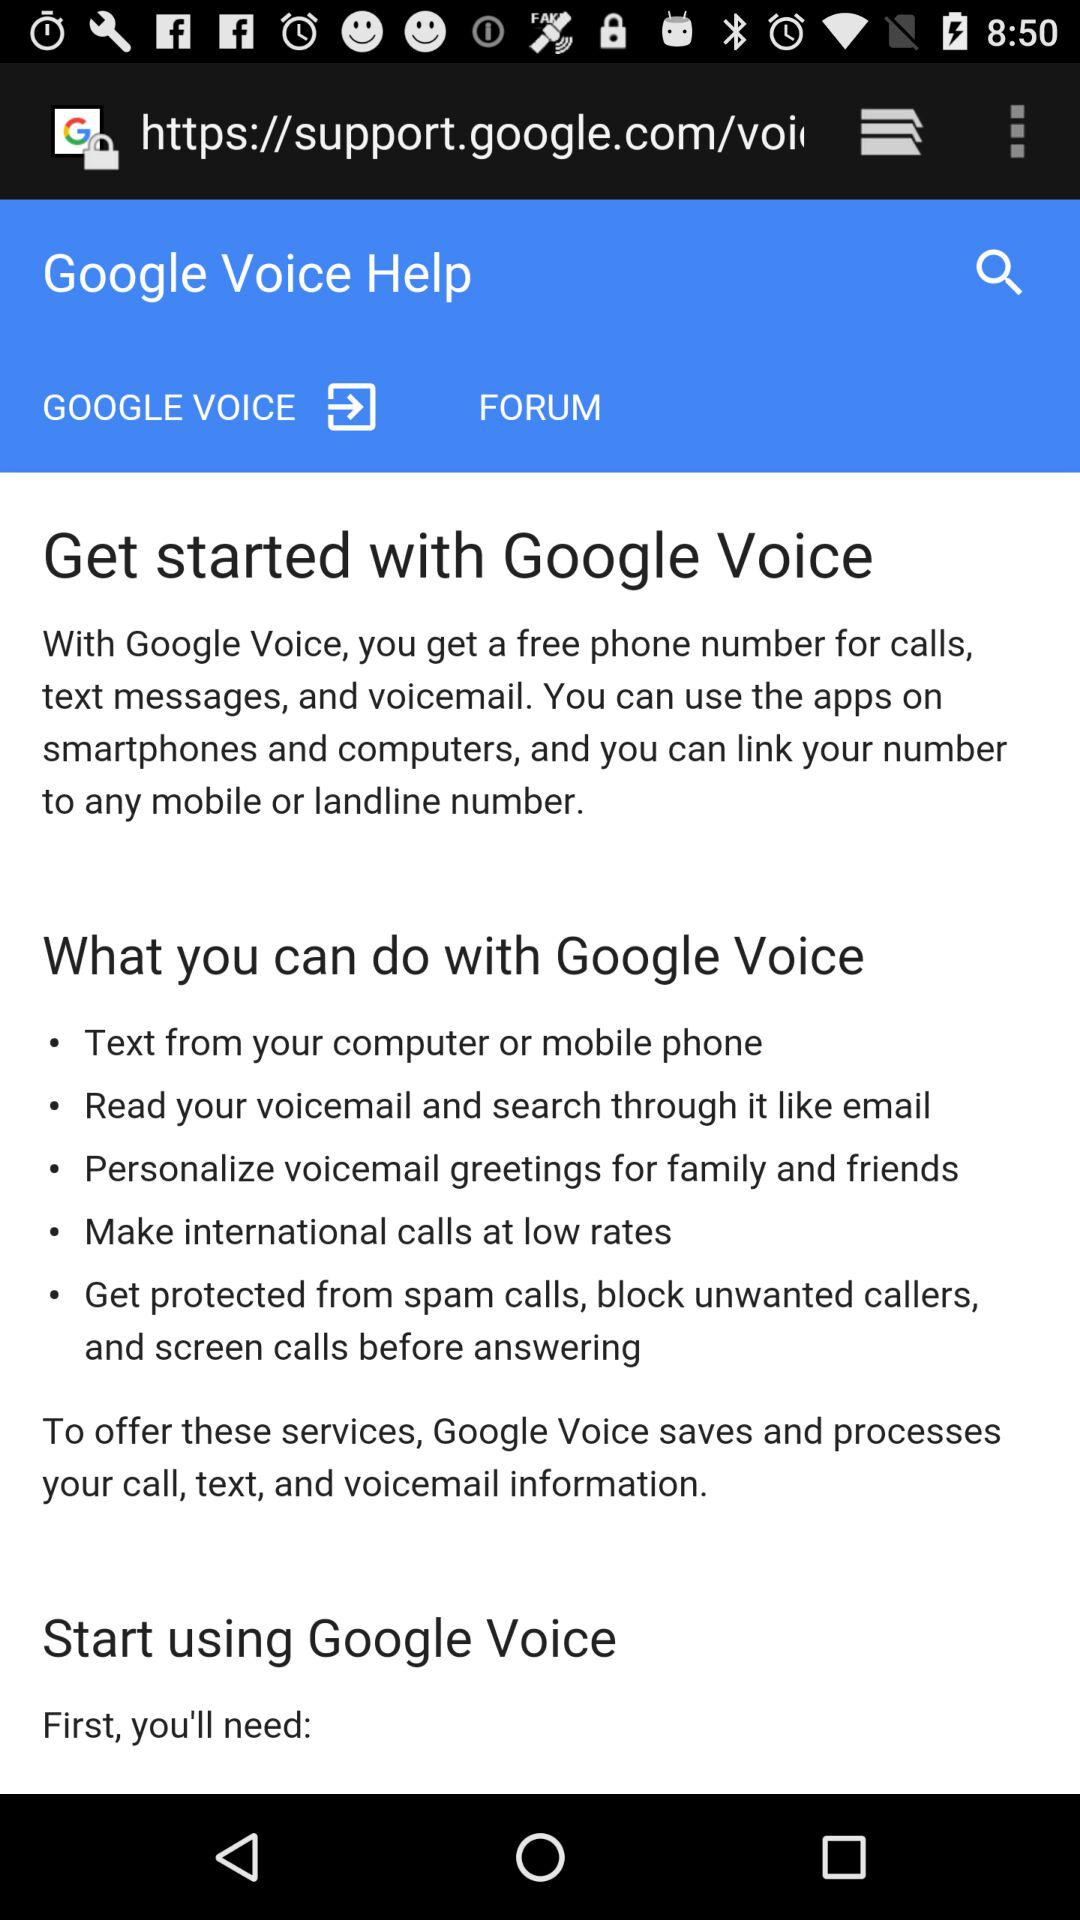For whom can we personalize voicemail greetings?
When the provided information is insufficient, respond with <no answer>. <no answer> 